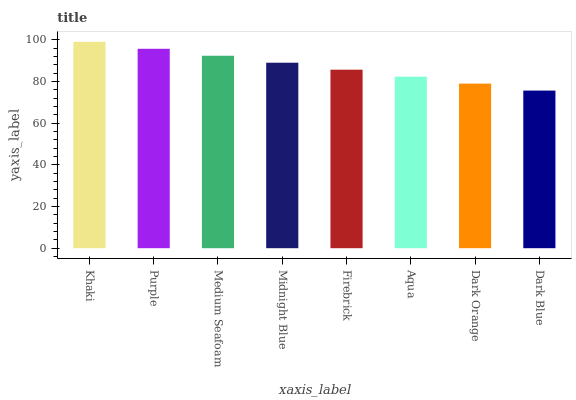Is Purple the minimum?
Answer yes or no. No. Is Purple the maximum?
Answer yes or no. No. Is Khaki greater than Purple?
Answer yes or no. Yes. Is Purple less than Khaki?
Answer yes or no. Yes. Is Purple greater than Khaki?
Answer yes or no. No. Is Khaki less than Purple?
Answer yes or no. No. Is Midnight Blue the high median?
Answer yes or no. Yes. Is Firebrick the low median?
Answer yes or no. Yes. Is Khaki the high median?
Answer yes or no. No. Is Dark Blue the low median?
Answer yes or no. No. 